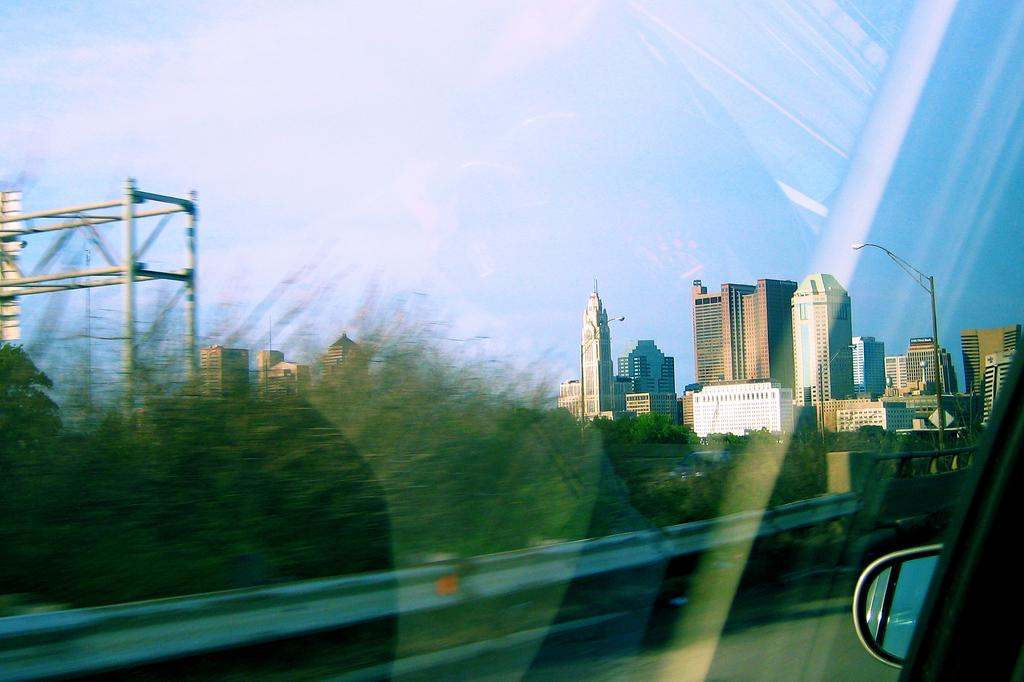What type of structures can be seen in the image? There are buildings in the image. What type of lighting is present in the image? There are street lights in the image. What type of vegetation is visible in the image? There are trees in the image. What is visible in the background of the image? The sky is visible in the background of the image. What level of force is required to fly the trees in the image? The trees in the image are not capable of flying, and therefore no force is required to make them fly. 